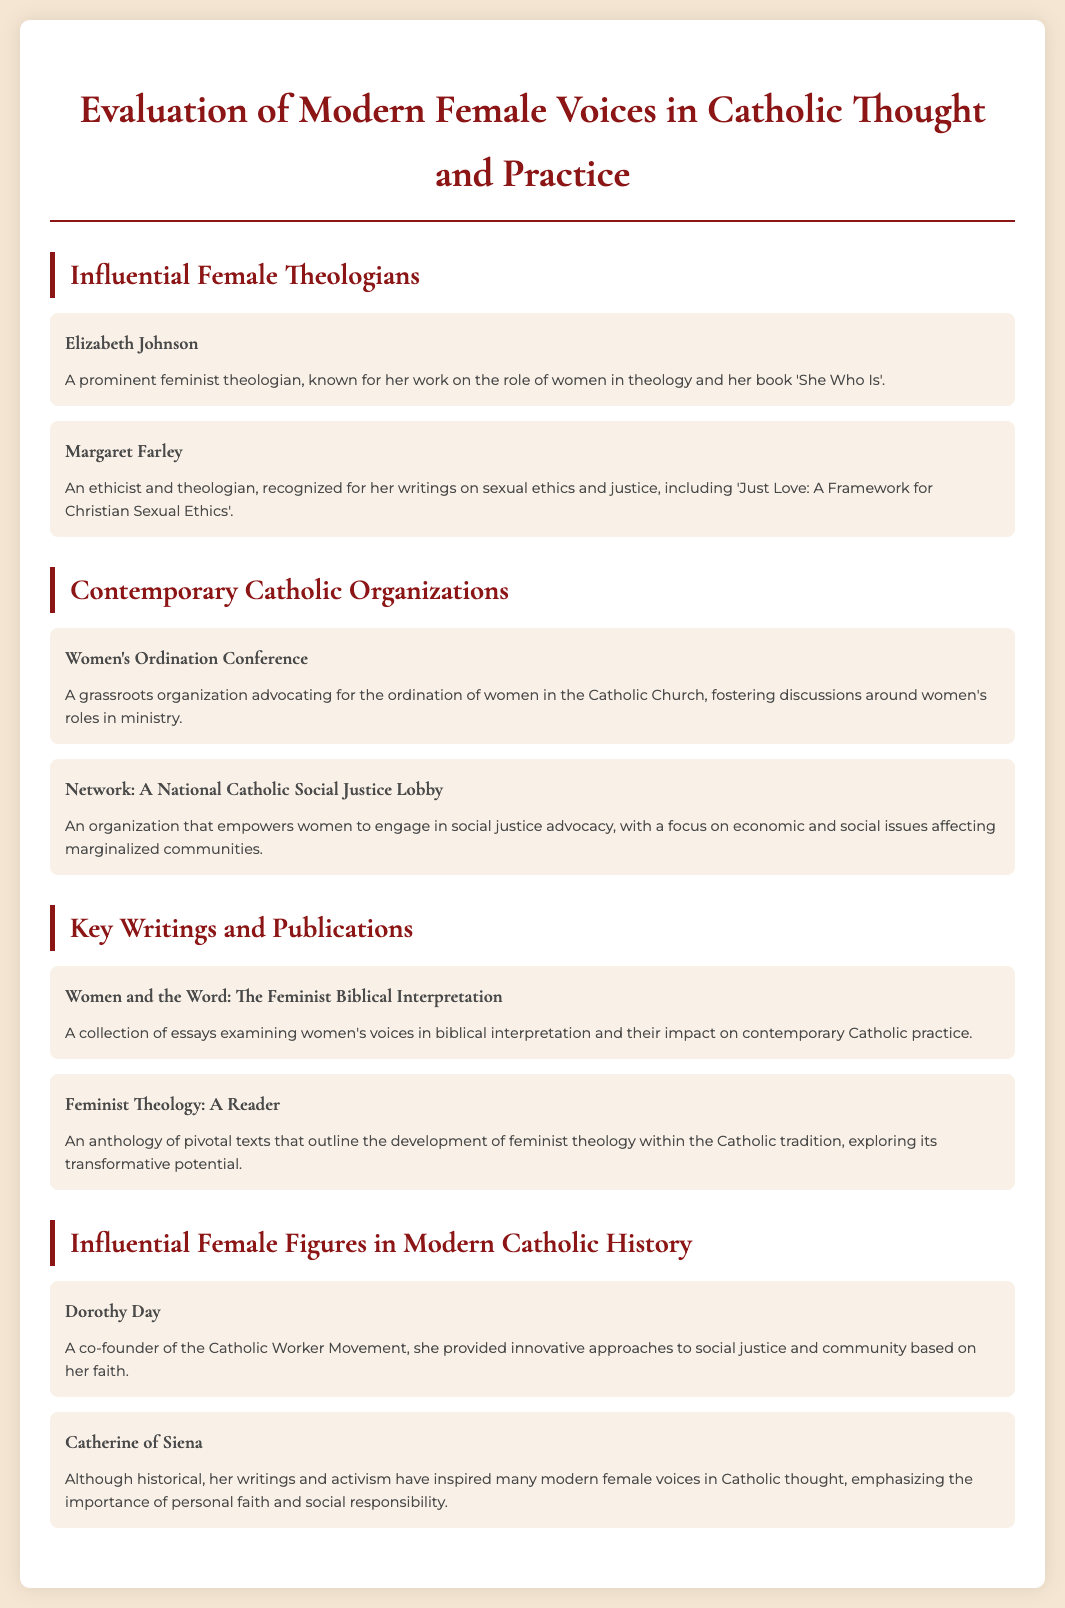What is the title of the document? The title of the document is stated at the top of the rendered page.
Answer: Evaluation of Modern Female Voices in Catholic Thought and Practice Who is a prominent feminist theologian mentioned in the document? The document lists several influential female theologians.
Answer: Elizabeth Johnson What organization advocates for the ordination of women in the Catholic Church? The document includes information about contemporary Catholic organizations.
Answer: Women's Ordination Conference Name the book written by Margaret Farley. The document provides key writings and authors in Catholic thought.
Answer: Just Love: A Framework for Christian Sexual Ethics Who is a co-founder of the Catholic Worker Movement? This person is recognized in the section about influential female figures in modern Catholic history.
Answer: Dorothy Day How many influential female theologians are listed in the document? The document has a section that details influential female theologians having specific contributors.
Answer: Two What is the focus of Network: A National Catholic Social Justice Lobby? The description of the organization indicates its primary mission.
Answer: Social justice advocacy Which historical figure is noted for inspiring modern female voices in Catholic thought? The document mentions influential figures in modern Catholic history.
Answer: Catherine of Siena 